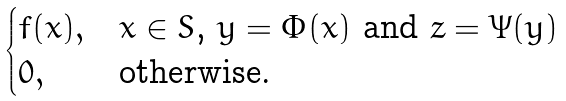Convert formula to latex. <formula><loc_0><loc_0><loc_500><loc_500>\begin{cases} f ( x ) , & \text {$x\in S$, $y=\Phi(x)$ and $z=\Psi(y)$} \\ 0 , & \text {otherwise.} \end{cases}</formula> 